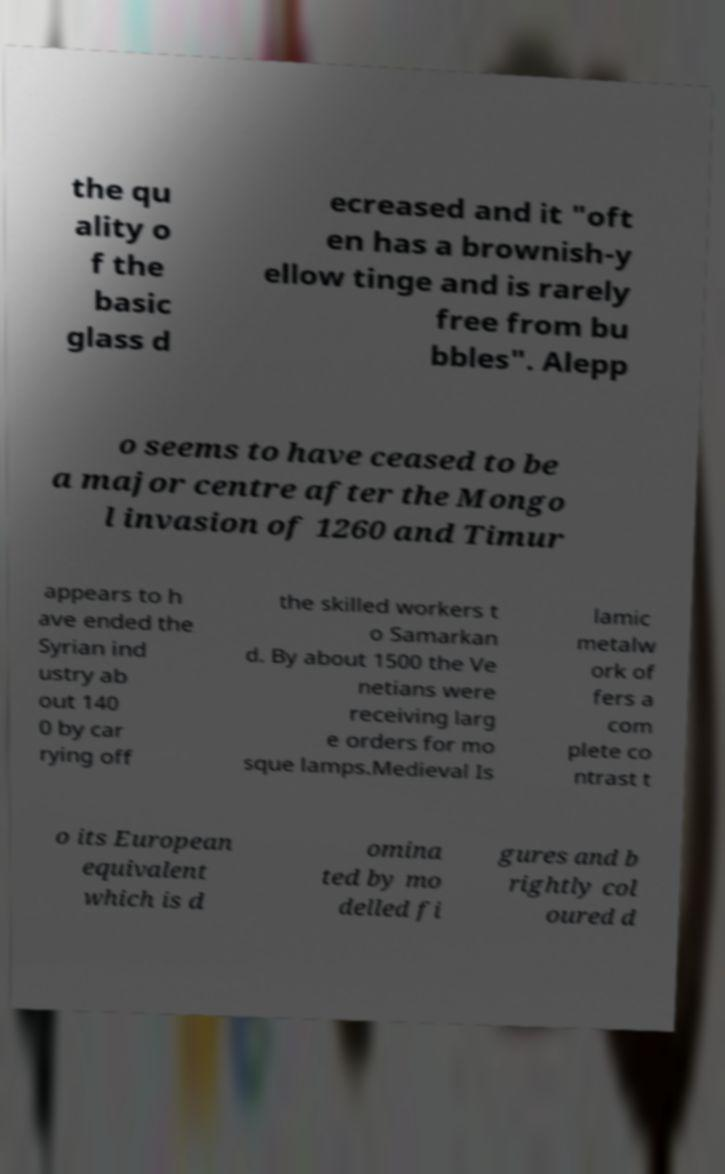Can you read and provide the text displayed in the image?This photo seems to have some interesting text. Can you extract and type it out for me? the qu ality o f the basic glass d ecreased and it "oft en has a brownish-y ellow tinge and is rarely free from bu bbles". Alepp o seems to have ceased to be a major centre after the Mongo l invasion of 1260 and Timur appears to h ave ended the Syrian ind ustry ab out 140 0 by car rying off the skilled workers t o Samarkan d. By about 1500 the Ve netians were receiving larg e orders for mo sque lamps.Medieval Is lamic metalw ork of fers a com plete co ntrast t o its European equivalent which is d omina ted by mo delled fi gures and b rightly col oured d 